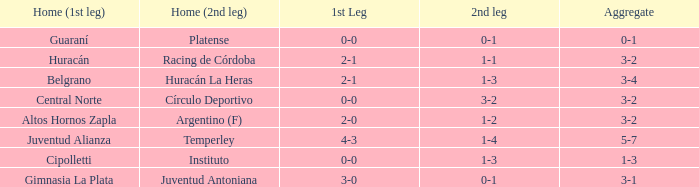In which team's home game did they achieve an aggregate score of 3-4 in the first leg? Belgrano. 